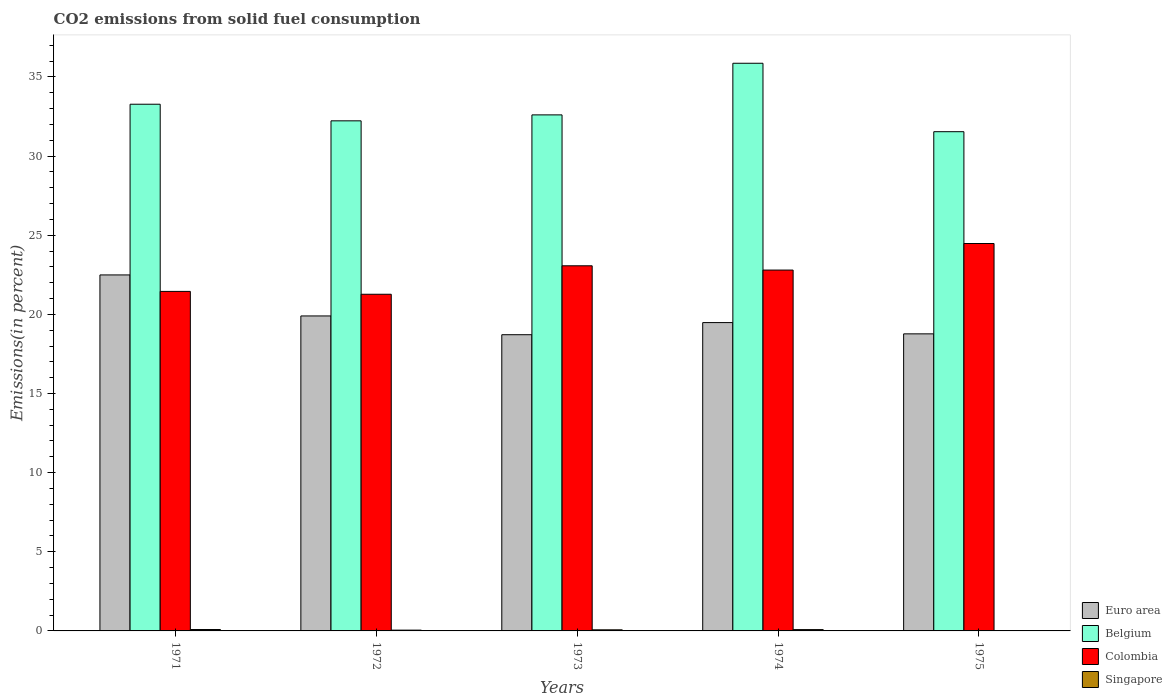How many bars are there on the 1st tick from the left?
Offer a terse response. 4. How many bars are there on the 3rd tick from the right?
Your answer should be very brief. 4. What is the total CO2 emitted in Belgium in 1971?
Provide a succinct answer. 33.28. Across all years, what is the maximum total CO2 emitted in Singapore?
Offer a very short reply. 0.09. Across all years, what is the minimum total CO2 emitted in Colombia?
Ensure brevity in your answer.  21.27. In which year was the total CO2 emitted in Colombia minimum?
Provide a short and direct response. 1972. What is the total total CO2 emitted in Colombia in the graph?
Make the answer very short. 113.06. What is the difference between the total CO2 emitted in Colombia in 1973 and that in 1974?
Your answer should be compact. 0.27. What is the difference between the total CO2 emitted in Euro area in 1974 and the total CO2 emitted in Singapore in 1972?
Ensure brevity in your answer.  19.43. What is the average total CO2 emitted in Euro area per year?
Your response must be concise. 19.87. In the year 1972, what is the difference between the total CO2 emitted in Belgium and total CO2 emitted in Colombia?
Your answer should be very brief. 10.96. In how many years, is the total CO2 emitted in Singapore greater than 25 %?
Provide a succinct answer. 0. What is the ratio of the total CO2 emitted in Euro area in 1972 to that in 1975?
Offer a very short reply. 1.06. Is the total CO2 emitted in Belgium in 1971 less than that in 1973?
Give a very brief answer. No. What is the difference between the highest and the second highest total CO2 emitted in Colombia?
Keep it short and to the point. 1.41. What is the difference between the highest and the lowest total CO2 emitted in Belgium?
Ensure brevity in your answer.  4.32. Is the sum of the total CO2 emitted in Singapore in 1971 and 1975 greater than the maximum total CO2 emitted in Euro area across all years?
Keep it short and to the point. No. What does the 3rd bar from the left in 1972 represents?
Provide a succinct answer. Colombia. What does the 1st bar from the right in 1972 represents?
Offer a very short reply. Singapore. How many bars are there?
Make the answer very short. 20. Are all the bars in the graph horizontal?
Make the answer very short. No. How many years are there in the graph?
Provide a short and direct response. 5. Are the values on the major ticks of Y-axis written in scientific E-notation?
Give a very brief answer. No. Does the graph contain any zero values?
Offer a terse response. No. Does the graph contain grids?
Your response must be concise. No. What is the title of the graph?
Offer a very short reply. CO2 emissions from solid fuel consumption. What is the label or title of the Y-axis?
Provide a succinct answer. Emissions(in percent). What is the Emissions(in percent) in Euro area in 1971?
Give a very brief answer. 22.49. What is the Emissions(in percent) in Belgium in 1971?
Provide a short and direct response. 33.28. What is the Emissions(in percent) in Colombia in 1971?
Your answer should be compact. 21.45. What is the Emissions(in percent) of Singapore in 1971?
Your response must be concise. 0.09. What is the Emissions(in percent) of Euro area in 1972?
Your answer should be compact. 19.9. What is the Emissions(in percent) of Belgium in 1972?
Your answer should be compact. 32.23. What is the Emissions(in percent) in Colombia in 1972?
Make the answer very short. 21.27. What is the Emissions(in percent) of Singapore in 1972?
Provide a short and direct response. 0.05. What is the Emissions(in percent) of Euro area in 1973?
Your response must be concise. 18.71. What is the Emissions(in percent) in Belgium in 1973?
Provide a succinct answer. 32.6. What is the Emissions(in percent) of Colombia in 1973?
Your answer should be very brief. 23.07. What is the Emissions(in percent) in Singapore in 1973?
Make the answer very short. 0.07. What is the Emissions(in percent) of Euro area in 1974?
Provide a short and direct response. 19.48. What is the Emissions(in percent) of Belgium in 1974?
Offer a terse response. 35.86. What is the Emissions(in percent) in Colombia in 1974?
Offer a terse response. 22.8. What is the Emissions(in percent) of Singapore in 1974?
Offer a very short reply. 0.08. What is the Emissions(in percent) of Euro area in 1975?
Keep it short and to the point. 18.77. What is the Emissions(in percent) of Belgium in 1975?
Give a very brief answer. 31.54. What is the Emissions(in percent) of Colombia in 1975?
Offer a terse response. 24.48. What is the Emissions(in percent) of Singapore in 1975?
Provide a succinct answer. 0.01. Across all years, what is the maximum Emissions(in percent) of Euro area?
Provide a succinct answer. 22.49. Across all years, what is the maximum Emissions(in percent) in Belgium?
Make the answer very short. 35.86. Across all years, what is the maximum Emissions(in percent) in Colombia?
Your response must be concise. 24.48. Across all years, what is the maximum Emissions(in percent) of Singapore?
Offer a terse response. 0.09. Across all years, what is the minimum Emissions(in percent) in Euro area?
Provide a short and direct response. 18.71. Across all years, what is the minimum Emissions(in percent) of Belgium?
Your response must be concise. 31.54. Across all years, what is the minimum Emissions(in percent) of Colombia?
Your answer should be compact. 21.27. Across all years, what is the minimum Emissions(in percent) in Singapore?
Offer a very short reply. 0.01. What is the total Emissions(in percent) in Euro area in the graph?
Your response must be concise. 99.35. What is the total Emissions(in percent) of Belgium in the graph?
Your response must be concise. 165.51. What is the total Emissions(in percent) in Colombia in the graph?
Your response must be concise. 113.06. What is the total Emissions(in percent) in Singapore in the graph?
Keep it short and to the point. 0.31. What is the difference between the Emissions(in percent) of Euro area in 1971 and that in 1972?
Your answer should be very brief. 2.59. What is the difference between the Emissions(in percent) of Belgium in 1971 and that in 1972?
Offer a very short reply. 1.05. What is the difference between the Emissions(in percent) in Colombia in 1971 and that in 1972?
Your response must be concise. 0.18. What is the difference between the Emissions(in percent) of Singapore in 1971 and that in 1972?
Your response must be concise. 0.04. What is the difference between the Emissions(in percent) of Euro area in 1971 and that in 1973?
Provide a short and direct response. 3.78. What is the difference between the Emissions(in percent) of Belgium in 1971 and that in 1973?
Offer a very short reply. 0.67. What is the difference between the Emissions(in percent) in Colombia in 1971 and that in 1973?
Give a very brief answer. -1.62. What is the difference between the Emissions(in percent) in Singapore in 1971 and that in 1973?
Keep it short and to the point. 0.02. What is the difference between the Emissions(in percent) of Euro area in 1971 and that in 1974?
Make the answer very short. 3.01. What is the difference between the Emissions(in percent) in Belgium in 1971 and that in 1974?
Provide a succinct answer. -2.59. What is the difference between the Emissions(in percent) of Colombia in 1971 and that in 1974?
Make the answer very short. -1.35. What is the difference between the Emissions(in percent) in Singapore in 1971 and that in 1974?
Provide a succinct answer. 0. What is the difference between the Emissions(in percent) in Euro area in 1971 and that in 1975?
Offer a terse response. 3.72. What is the difference between the Emissions(in percent) in Belgium in 1971 and that in 1975?
Offer a very short reply. 1.74. What is the difference between the Emissions(in percent) of Colombia in 1971 and that in 1975?
Keep it short and to the point. -3.03. What is the difference between the Emissions(in percent) in Singapore in 1971 and that in 1975?
Your response must be concise. 0.07. What is the difference between the Emissions(in percent) of Euro area in 1972 and that in 1973?
Offer a terse response. 1.19. What is the difference between the Emissions(in percent) in Belgium in 1972 and that in 1973?
Provide a short and direct response. -0.38. What is the difference between the Emissions(in percent) of Colombia in 1972 and that in 1973?
Your answer should be compact. -1.8. What is the difference between the Emissions(in percent) in Singapore in 1972 and that in 1973?
Your answer should be compact. -0.02. What is the difference between the Emissions(in percent) of Euro area in 1972 and that in 1974?
Your answer should be very brief. 0.42. What is the difference between the Emissions(in percent) in Belgium in 1972 and that in 1974?
Give a very brief answer. -3.64. What is the difference between the Emissions(in percent) of Colombia in 1972 and that in 1974?
Provide a short and direct response. -1.53. What is the difference between the Emissions(in percent) in Singapore in 1972 and that in 1974?
Your response must be concise. -0.03. What is the difference between the Emissions(in percent) in Euro area in 1972 and that in 1975?
Ensure brevity in your answer.  1.13. What is the difference between the Emissions(in percent) of Belgium in 1972 and that in 1975?
Give a very brief answer. 0.69. What is the difference between the Emissions(in percent) of Colombia in 1972 and that in 1975?
Make the answer very short. -3.21. What is the difference between the Emissions(in percent) of Singapore in 1972 and that in 1975?
Provide a succinct answer. 0.03. What is the difference between the Emissions(in percent) of Euro area in 1973 and that in 1974?
Ensure brevity in your answer.  -0.77. What is the difference between the Emissions(in percent) in Belgium in 1973 and that in 1974?
Your response must be concise. -3.26. What is the difference between the Emissions(in percent) in Colombia in 1973 and that in 1974?
Ensure brevity in your answer.  0.27. What is the difference between the Emissions(in percent) of Singapore in 1973 and that in 1974?
Offer a terse response. -0.01. What is the difference between the Emissions(in percent) in Euro area in 1973 and that in 1975?
Keep it short and to the point. -0.05. What is the difference between the Emissions(in percent) of Belgium in 1973 and that in 1975?
Ensure brevity in your answer.  1.06. What is the difference between the Emissions(in percent) in Colombia in 1973 and that in 1975?
Your answer should be compact. -1.41. What is the difference between the Emissions(in percent) in Singapore in 1973 and that in 1975?
Your response must be concise. 0.05. What is the difference between the Emissions(in percent) in Euro area in 1974 and that in 1975?
Provide a succinct answer. 0.71. What is the difference between the Emissions(in percent) in Belgium in 1974 and that in 1975?
Offer a very short reply. 4.32. What is the difference between the Emissions(in percent) in Colombia in 1974 and that in 1975?
Offer a very short reply. -1.68. What is the difference between the Emissions(in percent) in Singapore in 1974 and that in 1975?
Make the answer very short. 0.07. What is the difference between the Emissions(in percent) of Euro area in 1971 and the Emissions(in percent) of Belgium in 1972?
Make the answer very short. -9.74. What is the difference between the Emissions(in percent) of Euro area in 1971 and the Emissions(in percent) of Colombia in 1972?
Offer a terse response. 1.22. What is the difference between the Emissions(in percent) of Euro area in 1971 and the Emissions(in percent) of Singapore in 1972?
Offer a terse response. 22.44. What is the difference between the Emissions(in percent) of Belgium in 1971 and the Emissions(in percent) of Colombia in 1972?
Make the answer very short. 12.01. What is the difference between the Emissions(in percent) of Belgium in 1971 and the Emissions(in percent) of Singapore in 1972?
Ensure brevity in your answer.  33.23. What is the difference between the Emissions(in percent) in Colombia in 1971 and the Emissions(in percent) in Singapore in 1972?
Ensure brevity in your answer.  21.4. What is the difference between the Emissions(in percent) of Euro area in 1971 and the Emissions(in percent) of Belgium in 1973?
Your answer should be very brief. -10.11. What is the difference between the Emissions(in percent) of Euro area in 1971 and the Emissions(in percent) of Colombia in 1973?
Offer a terse response. -0.58. What is the difference between the Emissions(in percent) of Euro area in 1971 and the Emissions(in percent) of Singapore in 1973?
Give a very brief answer. 22.42. What is the difference between the Emissions(in percent) in Belgium in 1971 and the Emissions(in percent) in Colombia in 1973?
Give a very brief answer. 10.21. What is the difference between the Emissions(in percent) of Belgium in 1971 and the Emissions(in percent) of Singapore in 1973?
Keep it short and to the point. 33.21. What is the difference between the Emissions(in percent) in Colombia in 1971 and the Emissions(in percent) in Singapore in 1973?
Ensure brevity in your answer.  21.38. What is the difference between the Emissions(in percent) in Euro area in 1971 and the Emissions(in percent) in Belgium in 1974?
Your answer should be very brief. -13.37. What is the difference between the Emissions(in percent) of Euro area in 1971 and the Emissions(in percent) of Colombia in 1974?
Your answer should be compact. -0.31. What is the difference between the Emissions(in percent) in Euro area in 1971 and the Emissions(in percent) in Singapore in 1974?
Provide a short and direct response. 22.41. What is the difference between the Emissions(in percent) of Belgium in 1971 and the Emissions(in percent) of Colombia in 1974?
Keep it short and to the point. 10.48. What is the difference between the Emissions(in percent) of Belgium in 1971 and the Emissions(in percent) of Singapore in 1974?
Offer a very short reply. 33.19. What is the difference between the Emissions(in percent) of Colombia in 1971 and the Emissions(in percent) of Singapore in 1974?
Provide a succinct answer. 21.37. What is the difference between the Emissions(in percent) of Euro area in 1971 and the Emissions(in percent) of Belgium in 1975?
Make the answer very short. -9.05. What is the difference between the Emissions(in percent) in Euro area in 1971 and the Emissions(in percent) in Colombia in 1975?
Offer a terse response. -1.99. What is the difference between the Emissions(in percent) of Euro area in 1971 and the Emissions(in percent) of Singapore in 1975?
Offer a very short reply. 22.48. What is the difference between the Emissions(in percent) in Belgium in 1971 and the Emissions(in percent) in Colombia in 1975?
Give a very brief answer. 8.8. What is the difference between the Emissions(in percent) of Belgium in 1971 and the Emissions(in percent) of Singapore in 1975?
Offer a very short reply. 33.26. What is the difference between the Emissions(in percent) of Colombia in 1971 and the Emissions(in percent) of Singapore in 1975?
Your answer should be compact. 21.44. What is the difference between the Emissions(in percent) in Euro area in 1972 and the Emissions(in percent) in Belgium in 1973?
Your answer should be very brief. -12.7. What is the difference between the Emissions(in percent) in Euro area in 1972 and the Emissions(in percent) in Colombia in 1973?
Offer a very short reply. -3.17. What is the difference between the Emissions(in percent) of Euro area in 1972 and the Emissions(in percent) of Singapore in 1973?
Ensure brevity in your answer.  19.83. What is the difference between the Emissions(in percent) of Belgium in 1972 and the Emissions(in percent) of Colombia in 1973?
Your answer should be compact. 9.16. What is the difference between the Emissions(in percent) of Belgium in 1972 and the Emissions(in percent) of Singapore in 1973?
Provide a succinct answer. 32.16. What is the difference between the Emissions(in percent) of Colombia in 1972 and the Emissions(in percent) of Singapore in 1973?
Provide a succinct answer. 21.2. What is the difference between the Emissions(in percent) in Euro area in 1972 and the Emissions(in percent) in Belgium in 1974?
Your answer should be compact. -15.96. What is the difference between the Emissions(in percent) in Euro area in 1972 and the Emissions(in percent) in Colombia in 1974?
Ensure brevity in your answer.  -2.9. What is the difference between the Emissions(in percent) in Euro area in 1972 and the Emissions(in percent) in Singapore in 1974?
Give a very brief answer. 19.82. What is the difference between the Emissions(in percent) of Belgium in 1972 and the Emissions(in percent) of Colombia in 1974?
Your answer should be compact. 9.43. What is the difference between the Emissions(in percent) of Belgium in 1972 and the Emissions(in percent) of Singapore in 1974?
Offer a very short reply. 32.14. What is the difference between the Emissions(in percent) of Colombia in 1972 and the Emissions(in percent) of Singapore in 1974?
Your answer should be very brief. 21.19. What is the difference between the Emissions(in percent) in Euro area in 1972 and the Emissions(in percent) in Belgium in 1975?
Offer a terse response. -11.64. What is the difference between the Emissions(in percent) of Euro area in 1972 and the Emissions(in percent) of Colombia in 1975?
Give a very brief answer. -4.58. What is the difference between the Emissions(in percent) of Euro area in 1972 and the Emissions(in percent) of Singapore in 1975?
Your response must be concise. 19.89. What is the difference between the Emissions(in percent) of Belgium in 1972 and the Emissions(in percent) of Colombia in 1975?
Provide a short and direct response. 7.75. What is the difference between the Emissions(in percent) in Belgium in 1972 and the Emissions(in percent) in Singapore in 1975?
Provide a short and direct response. 32.21. What is the difference between the Emissions(in percent) of Colombia in 1972 and the Emissions(in percent) of Singapore in 1975?
Provide a succinct answer. 21.25. What is the difference between the Emissions(in percent) in Euro area in 1973 and the Emissions(in percent) in Belgium in 1974?
Keep it short and to the point. -17.15. What is the difference between the Emissions(in percent) of Euro area in 1973 and the Emissions(in percent) of Colombia in 1974?
Give a very brief answer. -4.08. What is the difference between the Emissions(in percent) in Euro area in 1973 and the Emissions(in percent) in Singapore in 1974?
Provide a short and direct response. 18.63. What is the difference between the Emissions(in percent) in Belgium in 1973 and the Emissions(in percent) in Colombia in 1974?
Offer a very short reply. 9.8. What is the difference between the Emissions(in percent) of Belgium in 1973 and the Emissions(in percent) of Singapore in 1974?
Offer a very short reply. 32.52. What is the difference between the Emissions(in percent) of Colombia in 1973 and the Emissions(in percent) of Singapore in 1974?
Your response must be concise. 22.99. What is the difference between the Emissions(in percent) of Euro area in 1973 and the Emissions(in percent) of Belgium in 1975?
Offer a terse response. -12.83. What is the difference between the Emissions(in percent) in Euro area in 1973 and the Emissions(in percent) in Colombia in 1975?
Make the answer very short. -5.76. What is the difference between the Emissions(in percent) of Euro area in 1973 and the Emissions(in percent) of Singapore in 1975?
Your answer should be compact. 18.7. What is the difference between the Emissions(in percent) in Belgium in 1973 and the Emissions(in percent) in Colombia in 1975?
Keep it short and to the point. 8.13. What is the difference between the Emissions(in percent) of Belgium in 1973 and the Emissions(in percent) of Singapore in 1975?
Give a very brief answer. 32.59. What is the difference between the Emissions(in percent) in Colombia in 1973 and the Emissions(in percent) in Singapore in 1975?
Keep it short and to the point. 23.05. What is the difference between the Emissions(in percent) in Euro area in 1974 and the Emissions(in percent) in Belgium in 1975?
Your answer should be very brief. -12.06. What is the difference between the Emissions(in percent) in Euro area in 1974 and the Emissions(in percent) in Colombia in 1975?
Offer a very short reply. -5. What is the difference between the Emissions(in percent) in Euro area in 1974 and the Emissions(in percent) in Singapore in 1975?
Your answer should be compact. 19.47. What is the difference between the Emissions(in percent) of Belgium in 1974 and the Emissions(in percent) of Colombia in 1975?
Give a very brief answer. 11.39. What is the difference between the Emissions(in percent) in Belgium in 1974 and the Emissions(in percent) in Singapore in 1975?
Keep it short and to the point. 35.85. What is the difference between the Emissions(in percent) in Colombia in 1974 and the Emissions(in percent) in Singapore in 1975?
Offer a very short reply. 22.78. What is the average Emissions(in percent) of Euro area per year?
Your response must be concise. 19.87. What is the average Emissions(in percent) of Belgium per year?
Provide a succinct answer. 33.1. What is the average Emissions(in percent) in Colombia per year?
Your answer should be compact. 22.61. What is the average Emissions(in percent) of Singapore per year?
Your response must be concise. 0.06. In the year 1971, what is the difference between the Emissions(in percent) in Euro area and Emissions(in percent) in Belgium?
Ensure brevity in your answer.  -10.79. In the year 1971, what is the difference between the Emissions(in percent) in Euro area and Emissions(in percent) in Colombia?
Give a very brief answer. 1.04. In the year 1971, what is the difference between the Emissions(in percent) in Euro area and Emissions(in percent) in Singapore?
Offer a very short reply. 22.4. In the year 1971, what is the difference between the Emissions(in percent) in Belgium and Emissions(in percent) in Colombia?
Your answer should be compact. 11.82. In the year 1971, what is the difference between the Emissions(in percent) of Belgium and Emissions(in percent) of Singapore?
Ensure brevity in your answer.  33.19. In the year 1971, what is the difference between the Emissions(in percent) of Colombia and Emissions(in percent) of Singapore?
Offer a terse response. 21.36. In the year 1972, what is the difference between the Emissions(in percent) of Euro area and Emissions(in percent) of Belgium?
Your answer should be compact. -12.33. In the year 1972, what is the difference between the Emissions(in percent) in Euro area and Emissions(in percent) in Colombia?
Give a very brief answer. -1.37. In the year 1972, what is the difference between the Emissions(in percent) in Euro area and Emissions(in percent) in Singapore?
Offer a terse response. 19.85. In the year 1972, what is the difference between the Emissions(in percent) in Belgium and Emissions(in percent) in Colombia?
Provide a short and direct response. 10.96. In the year 1972, what is the difference between the Emissions(in percent) of Belgium and Emissions(in percent) of Singapore?
Give a very brief answer. 32.18. In the year 1972, what is the difference between the Emissions(in percent) in Colombia and Emissions(in percent) in Singapore?
Your answer should be compact. 21.22. In the year 1973, what is the difference between the Emissions(in percent) in Euro area and Emissions(in percent) in Belgium?
Provide a succinct answer. -13.89. In the year 1973, what is the difference between the Emissions(in percent) of Euro area and Emissions(in percent) of Colombia?
Offer a very short reply. -4.35. In the year 1973, what is the difference between the Emissions(in percent) in Euro area and Emissions(in percent) in Singapore?
Your response must be concise. 18.65. In the year 1973, what is the difference between the Emissions(in percent) of Belgium and Emissions(in percent) of Colombia?
Make the answer very short. 9.53. In the year 1973, what is the difference between the Emissions(in percent) of Belgium and Emissions(in percent) of Singapore?
Your answer should be very brief. 32.53. In the year 1973, what is the difference between the Emissions(in percent) of Colombia and Emissions(in percent) of Singapore?
Provide a short and direct response. 23. In the year 1974, what is the difference between the Emissions(in percent) of Euro area and Emissions(in percent) of Belgium?
Your response must be concise. -16.38. In the year 1974, what is the difference between the Emissions(in percent) of Euro area and Emissions(in percent) of Colombia?
Make the answer very short. -3.32. In the year 1974, what is the difference between the Emissions(in percent) in Euro area and Emissions(in percent) in Singapore?
Keep it short and to the point. 19.4. In the year 1974, what is the difference between the Emissions(in percent) in Belgium and Emissions(in percent) in Colombia?
Provide a short and direct response. 13.07. In the year 1974, what is the difference between the Emissions(in percent) in Belgium and Emissions(in percent) in Singapore?
Keep it short and to the point. 35.78. In the year 1974, what is the difference between the Emissions(in percent) of Colombia and Emissions(in percent) of Singapore?
Your answer should be very brief. 22.72. In the year 1975, what is the difference between the Emissions(in percent) in Euro area and Emissions(in percent) in Belgium?
Ensure brevity in your answer.  -12.77. In the year 1975, what is the difference between the Emissions(in percent) of Euro area and Emissions(in percent) of Colombia?
Give a very brief answer. -5.71. In the year 1975, what is the difference between the Emissions(in percent) in Euro area and Emissions(in percent) in Singapore?
Provide a short and direct response. 18.75. In the year 1975, what is the difference between the Emissions(in percent) in Belgium and Emissions(in percent) in Colombia?
Provide a succinct answer. 7.06. In the year 1975, what is the difference between the Emissions(in percent) in Belgium and Emissions(in percent) in Singapore?
Offer a very short reply. 31.53. In the year 1975, what is the difference between the Emissions(in percent) in Colombia and Emissions(in percent) in Singapore?
Provide a succinct answer. 24.46. What is the ratio of the Emissions(in percent) in Euro area in 1971 to that in 1972?
Give a very brief answer. 1.13. What is the ratio of the Emissions(in percent) in Belgium in 1971 to that in 1972?
Make the answer very short. 1.03. What is the ratio of the Emissions(in percent) of Colombia in 1971 to that in 1972?
Offer a very short reply. 1.01. What is the ratio of the Emissions(in percent) of Singapore in 1971 to that in 1972?
Provide a succinct answer. 1.79. What is the ratio of the Emissions(in percent) in Euro area in 1971 to that in 1973?
Your response must be concise. 1.2. What is the ratio of the Emissions(in percent) of Belgium in 1971 to that in 1973?
Provide a succinct answer. 1.02. What is the ratio of the Emissions(in percent) in Colombia in 1971 to that in 1973?
Offer a terse response. 0.93. What is the ratio of the Emissions(in percent) of Singapore in 1971 to that in 1973?
Give a very brief answer. 1.28. What is the ratio of the Emissions(in percent) in Euro area in 1971 to that in 1974?
Give a very brief answer. 1.15. What is the ratio of the Emissions(in percent) in Belgium in 1971 to that in 1974?
Provide a short and direct response. 0.93. What is the ratio of the Emissions(in percent) in Colombia in 1971 to that in 1974?
Make the answer very short. 0.94. What is the ratio of the Emissions(in percent) in Singapore in 1971 to that in 1974?
Offer a terse response. 1.06. What is the ratio of the Emissions(in percent) of Euro area in 1971 to that in 1975?
Provide a succinct answer. 1.2. What is the ratio of the Emissions(in percent) in Belgium in 1971 to that in 1975?
Provide a short and direct response. 1.05. What is the ratio of the Emissions(in percent) of Colombia in 1971 to that in 1975?
Keep it short and to the point. 0.88. What is the ratio of the Emissions(in percent) in Singapore in 1971 to that in 1975?
Give a very brief answer. 5.92. What is the ratio of the Emissions(in percent) of Euro area in 1972 to that in 1973?
Your answer should be compact. 1.06. What is the ratio of the Emissions(in percent) in Colombia in 1972 to that in 1973?
Provide a short and direct response. 0.92. What is the ratio of the Emissions(in percent) in Singapore in 1972 to that in 1973?
Keep it short and to the point. 0.72. What is the ratio of the Emissions(in percent) of Euro area in 1972 to that in 1974?
Provide a short and direct response. 1.02. What is the ratio of the Emissions(in percent) in Belgium in 1972 to that in 1974?
Offer a terse response. 0.9. What is the ratio of the Emissions(in percent) in Colombia in 1972 to that in 1974?
Your answer should be very brief. 0.93. What is the ratio of the Emissions(in percent) of Singapore in 1972 to that in 1974?
Keep it short and to the point. 0.59. What is the ratio of the Emissions(in percent) in Euro area in 1972 to that in 1975?
Keep it short and to the point. 1.06. What is the ratio of the Emissions(in percent) in Belgium in 1972 to that in 1975?
Make the answer very short. 1.02. What is the ratio of the Emissions(in percent) in Colombia in 1972 to that in 1975?
Your answer should be very brief. 0.87. What is the ratio of the Emissions(in percent) of Singapore in 1972 to that in 1975?
Make the answer very short. 3.31. What is the ratio of the Emissions(in percent) in Euro area in 1973 to that in 1974?
Offer a terse response. 0.96. What is the ratio of the Emissions(in percent) of Colombia in 1973 to that in 1974?
Your answer should be very brief. 1.01. What is the ratio of the Emissions(in percent) in Singapore in 1973 to that in 1974?
Offer a very short reply. 0.83. What is the ratio of the Emissions(in percent) in Euro area in 1973 to that in 1975?
Provide a short and direct response. 1. What is the ratio of the Emissions(in percent) of Belgium in 1973 to that in 1975?
Provide a short and direct response. 1.03. What is the ratio of the Emissions(in percent) of Colombia in 1973 to that in 1975?
Ensure brevity in your answer.  0.94. What is the ratio of the Emissions(in percent) in Singapore in 1973 to that in 1975?
Ensure brevity in your answer.  4.63. What is the ratio of the Emissions(in percent) in Euro area in 1974 to that in 1975?
Keep it short and to the point. 1.04. What is the ratio of the Emissions(in percent) in Belgium in 1974 to that in 1975?
Offer a terse response. 1.14. What is the ratio of the Emissions(in percent) of Colombia in 1974 to that in 1975?
Make the answer very short. 0.93. What is the ratio of the Emissions(in percent) of Singapore in 1974 to that in 1975?
Your answer should be compact. 5.59. What is the difference between the highest and the second highest Emissions(in percent) of Euro area?
Make the answer very short. 2.59. What is the difference between the highest and the second highest Emissions(in percent) of Belgium?
Ensure brevity in your answer.  2.59. What is the difference between the highest and the second highest Emissions(in percent) in Colombia?
Your answer should be very brief. 1.41. What is the difference between the highest and the second highest Emissions(in percent) of Singapore?
Your answer should be compact. 0. What is the difference between the highest and the lowest Emissions(in percent) of Euro area?
Your answer should be compact. 3.78. What is the difference between the highest and the lowest Emissions(in percent) in Belgium?
Your response must be concise. 4.32. What is the difference between the highest and the lowest Emissions(in percent) in Colombia?
Keep it short and to the point. 3.21. What is the difference between the highest and the lowest Emissions(in percent) in Singapore?
Your answer should be very brief. 0.07. 